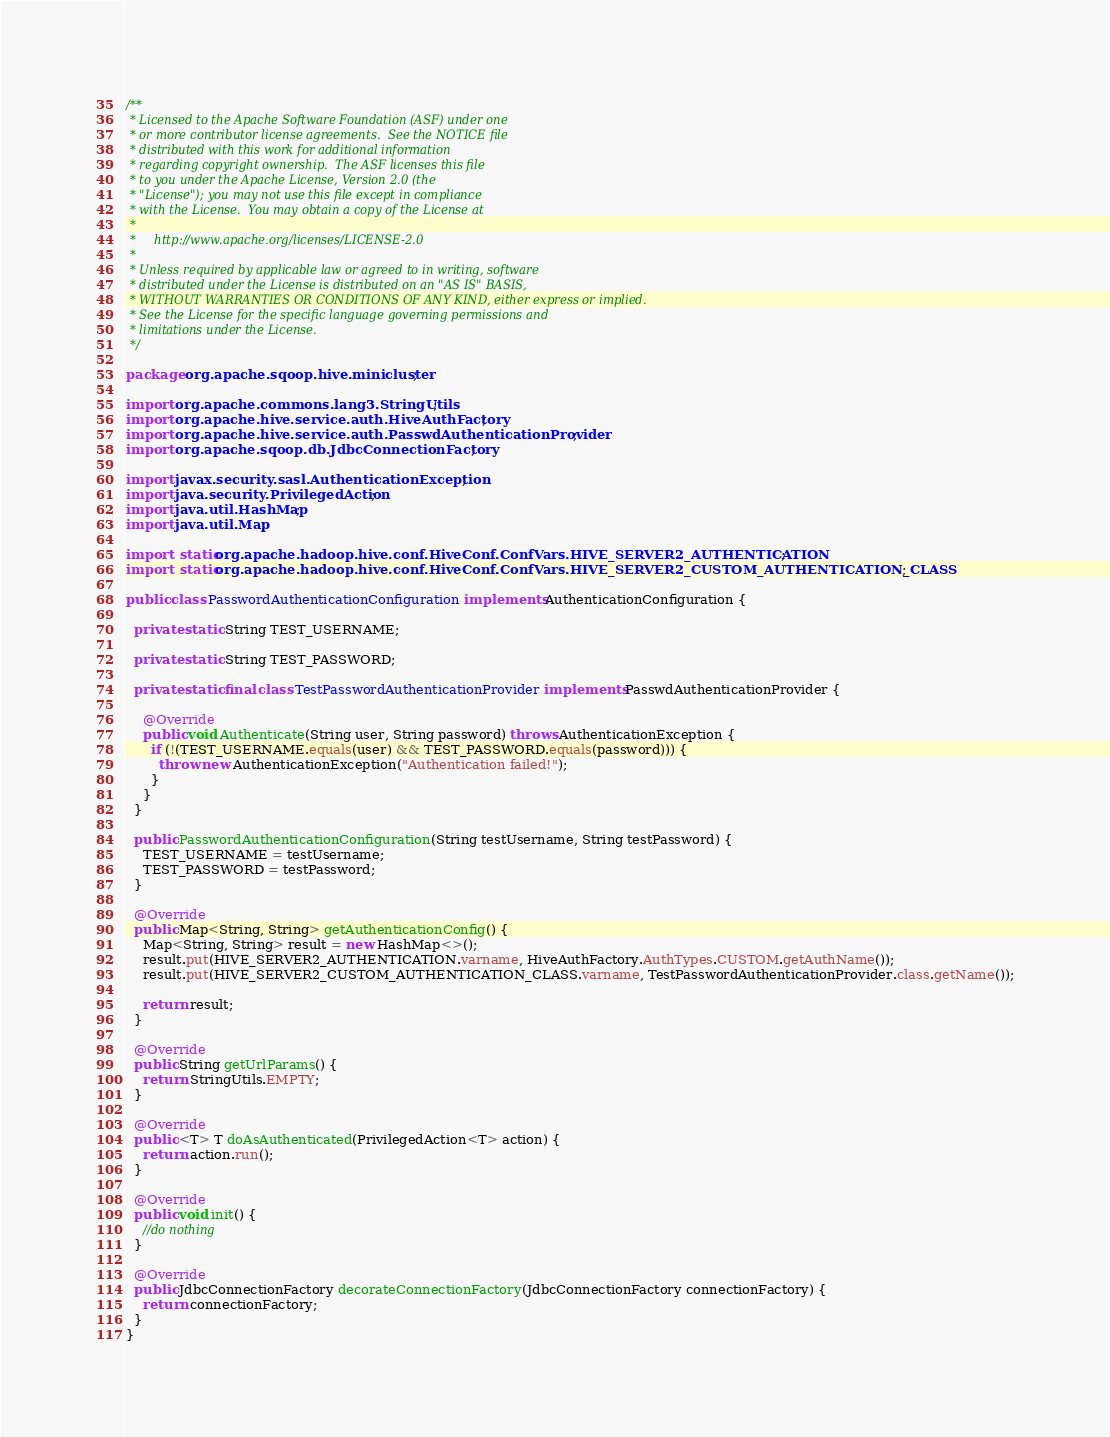<code> <loc_0><loc_0><loc_500><loc_500><_Java_>/**
 * Licensed to the Apache Software Foundation (ASF) under one
 * or more contributor license agreements.  See the NOTICE file
 * distributed with this work for additional information
 * regarding copyright ownership.  The ASF licenses this file
 * to you under the Apache License, Version 2.0 (the
 * "License"); you may not use this file except in compliance
 * with the License.  You may obtain a copy of the License at
 *
 *     http://www.apache.org/licenses/LICENSE-2.0
 *
 * Unless required by applicable law or agreed to in writing, software
 * distributed under the License is distributed on an "AS IS" BASIS,
 * WITHOUT WARRANTIES OR CONDITIONS OF ANY KIND, either express or implied.
 * See the License for the specific language governing permissions and
 * limitations under the License.
 */

package org.apache.sqoop.hive.minicluster;

import org.apache.commons.lang3.StringUtils;
import org.apache.hive.service.auth.HiveAuthFactory;
import org.apache.hive.service.auth.PasswdAuthenticationProvider;
import org.apache.sqoop.db.JdbcConnectionFactory;

import javax.security.sasl.AuthenticationException;
import java.security.PrivilegedAction;
import java.util.HashMap;
import java.util.Map;

import static org.apache.hadoop.hive.conf.HiveConf.ConfVars.HIVE_SERVER2_AUTHENTICATION;
import static org.apache.hadoop.hive.conf.HiveConf.ConfVars.HIVE_SERVER2_CUSTOM_AUTHENTICATION_CLASS;

public class PasswordAuthenticationConfiguration implements AuthenticationConfiguration {

  private static String TEST_USERNAME;

  private static String TEST_PASSWORD;

  private static final class TestPasswordAuthenticationProvider implements PasswdAuthenticationProvider {

    @Override
    public void Authenticate(String user, String password) throws AuthenticationException {
      if (!(TEST_USERNAME.equals(user) && TEST_PASSWORD.equals(password))) {
        throw new AuthenticationException("Authentication failed!");
      }
    }
  }

  public PasswordAuthenticationConfiguration(String testUsername, String testPassword) {
    TEST_USERNAME = testUsername;
    TEST_PASSWORD = testPassword;
  }

  @Override
  public Map<String, String> getAuthenticationConfig() {
    Map<String, String> result = new HashMap<>();
    result.put(HIVE_SERVER2_AUTHENTICATION.varname, HiveAuthFactory.AuthTypes.CUSTOM.getAuthName());
    result.put(HIVE_SERVER2_CUSTOM_AUTHENTICATION_CLASS.varname, TestPasswordAuthenticationProvider.class.getName());

    return result;
  }

  @Override
  public String getUrlParams() {
    return StringUtils.EMPTY;
  }

  @Override
  public <T> T doAsAuthenticated(PrivilegedAction<T> action) {
    return action.run();
  }

  @Override
  public void init() {
    //do nothing
  }

  @Override
  public JdbcConnectionFactory decorateConnectionFactory(JdbcConnectionFactory connectionFactory) {
    return connectionFactory;
  }
}
</code> 